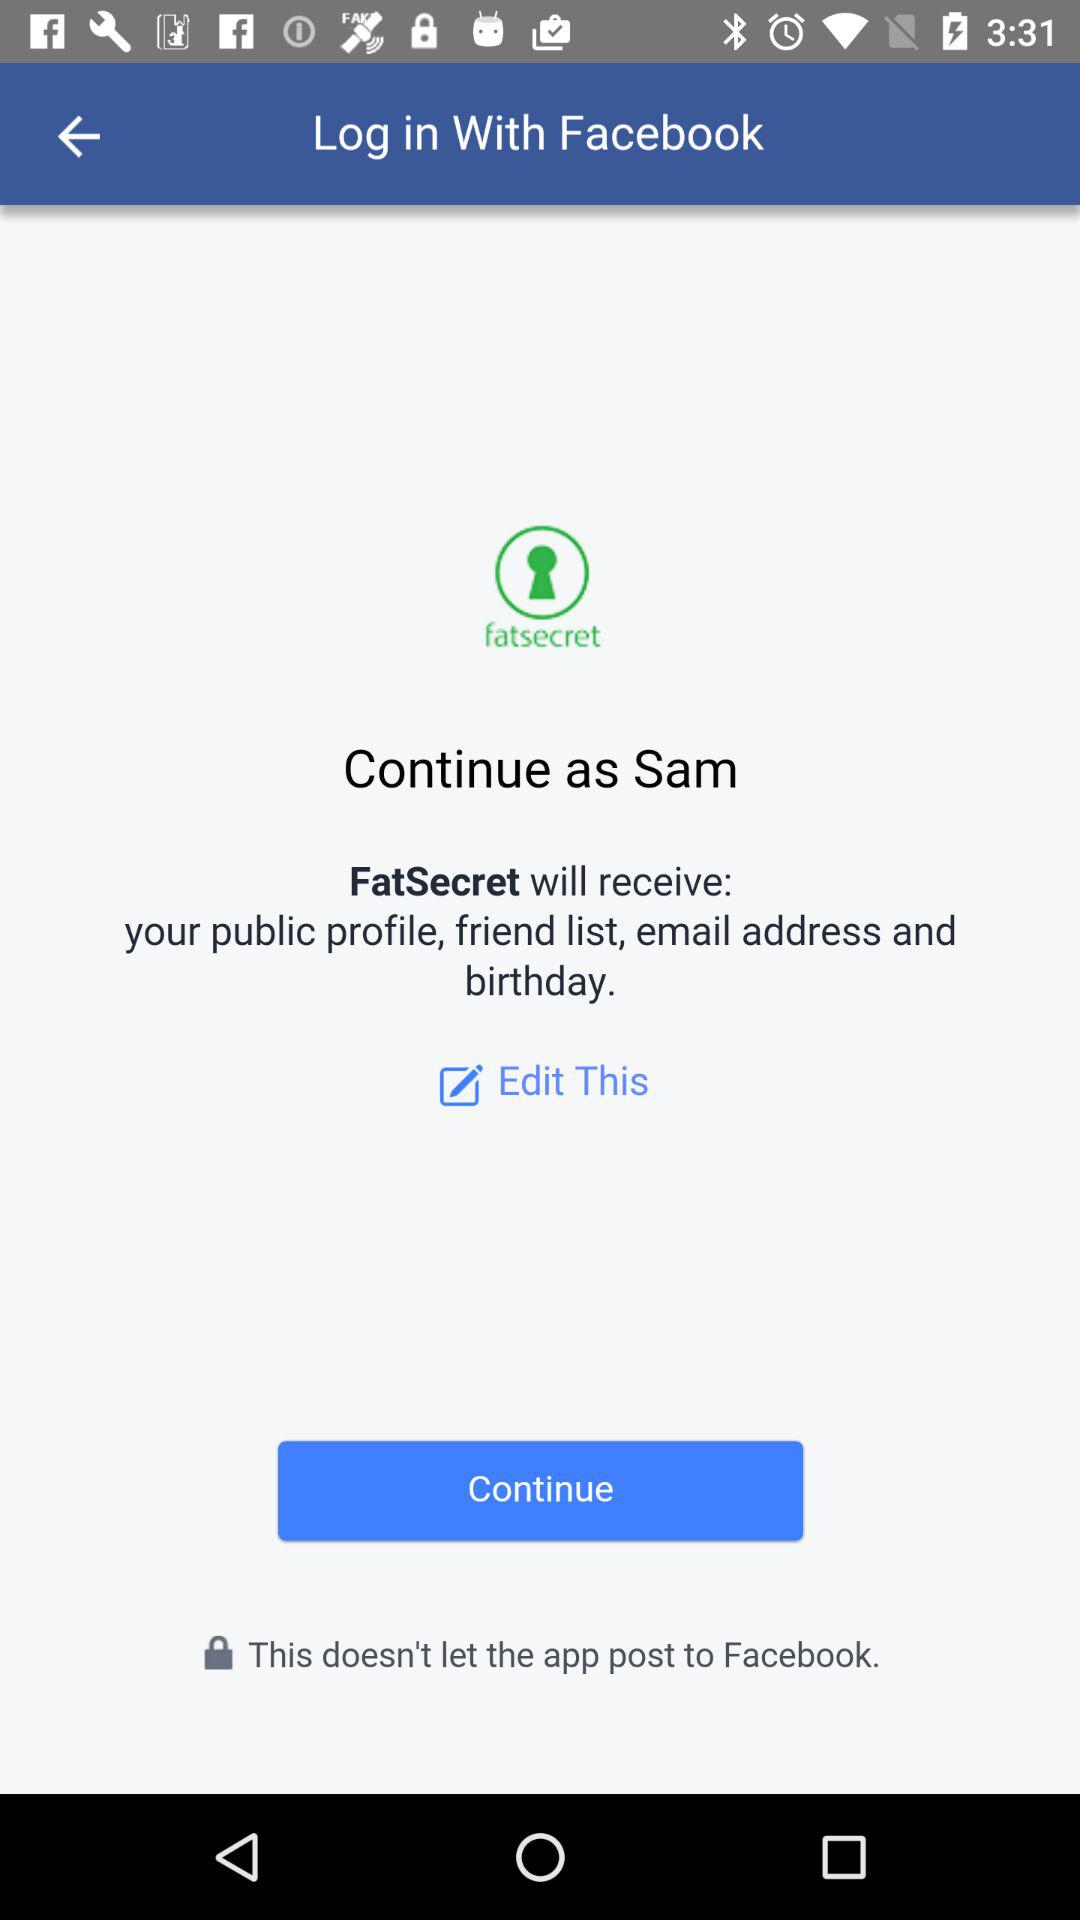Through what application can we log in? You can login with "Facebook". 